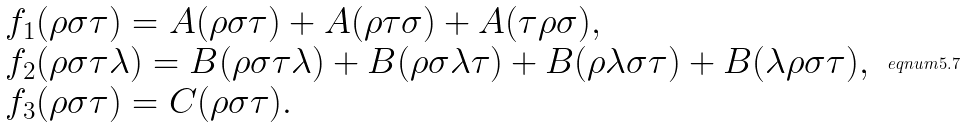<formula> <loc_0><loc_0><loc_500><loc_500>\begin{array} { l } f _ { 1 } ( \rho \sigma \tau ) = A ( \rho \sigma \tau ) + A ( \rho \tau \sigma ) + A ( \tau \rho \sigma ) , \\ f _ { 2 } ( \rho \sigma \tau \lambda ) = B ( \rho \sigma \tau \lambda ) + B ( \rho \sigma \lambda \tau ) + B ( \rho \lambda \sigma \tau ) + B ( \lambda \rho \sigma \tau ) , \\ f _ { 3 } ( \rho \sigma \tau ) = C ( \rho \sigma \tau ) . \end{array} \ e q n u m { 5 . 7 }</formula> 